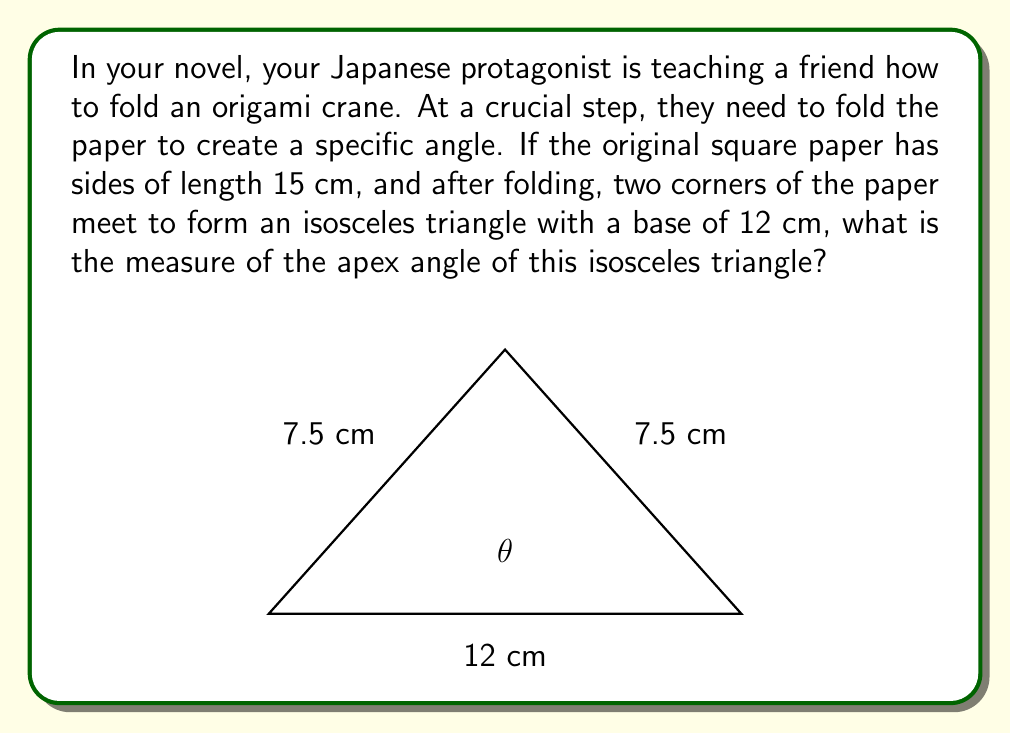Solve this math problem. Let's approach this step-by-step:

1) The original paper is a square with sides of 15 cm. When folded, two corners meet, forming an isosceles triangle.

2) The base of this isosceles triangle is 12 cm, which means the two equal sides are each half of the diagonal of the original square.

3) To find the length of these sides, we can use the Pythagorean theorem on the original square:
   $$diagonal^2 = 15^2 + 15^2 = 450$$
   $$diagonal = \sqrt{450} = 15\sqrt{2} \approx 21.21 \text{ cm}$$

4) Each equal side of the isosceles triangle is half of this:
   $$side = \frac{15\sqrt{2}}{2} = \frac{15}{\sqrt{2}} \approx 10.61 \text{ cm}$$

5) Now we have an isosceles triangle with two sides of $\frac{15}{\sqrt{2}}$ cm and a base of 12 cm.

6) To find the apex angle, we can use the cosine law:
   $$\cos \theta = \frac{a^2 + b^2 - c^2}{2ab}$$
   where $a$ and $b$ are the equal sides, and $c$ is the base.

7) Plugging in our values:
   $$\cos \theta = \frac{(\frac{15}{\sqrt{2}})^2 + (\frac{15}{\sqrt{2}})^2 - 12^2}{2(\frac{15}{\sqrt{2}})(\frac{15}{\sqrt{2}})}$$

8) Simplifying:
   $$\cos \theta = \frac{2(\frac{225}{2}) - 144}{450} = \frac{81}{450} = \frac{9}{50}$$

9) Therefore:
   $$\theta = \arccos(\frac{9}{50}) \approx 79.49°$$
Answer: The measure of the apex angle of the isosceles triangle is approximately 79.49°. 